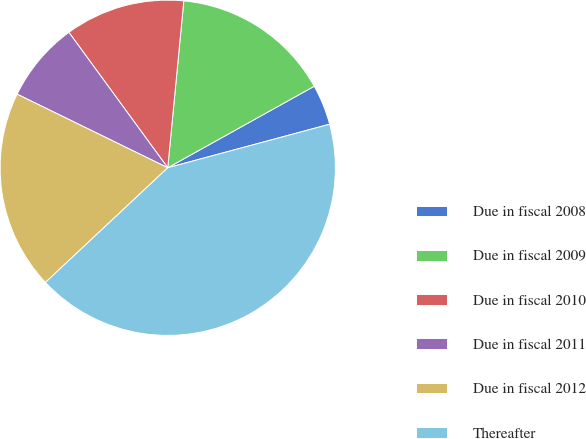Convert chart to OTSL. <chart><loc_0><loc_0><loc_500><loc_500><pie_chart><fcel>Due in fiscal 2008<fcel>Due in fiscal 2009<fcel>Due in fiscal 2010<fcel>Due in fiscal 2011<fcel>Due in fiscal 2012<fcel>Thereafter<nl><fcel>3.9%<fcel>15.39%<fcel>11.56%<fcel>7.73%<fcel>19.22%<fcel>42.19%<nl></chart> 